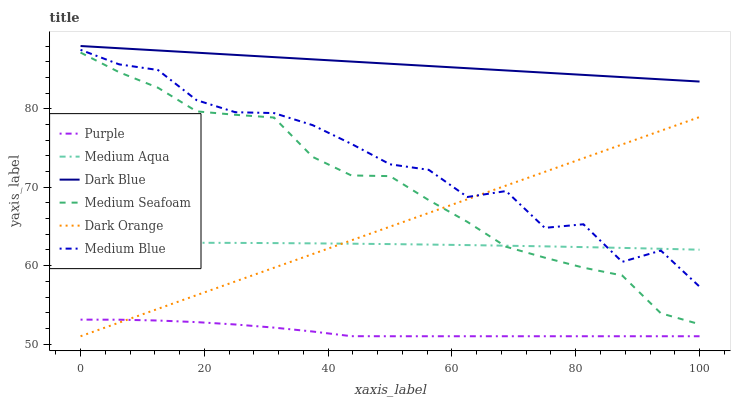Does Purple have the minimum area under the curve?
Answer yes or no. Yes. Does Dark Blue have the maximum area under the curve?
Answer yes or no. Yes. Does Medium Blue have the minimum area under the curve?
Answer yes or no. No. Does Medium Blue have the maximum area under the curve?
Answer yes or no. No. Is Dark Orange the smoothest?
Answer yes or no. Yes. Is Medium Blue the roughest?
Answer yes or no. Yes. Is Purple the smoothest?
Answer yes or no. No. Is Purple the roughest?
Answer yes or no. No. Does Dark Orange have the lowest value?
Answer yes or no. Yes. Does Medium Blue have the lowest value?
Answer yes or no. No. Does Dark Blue have the highest value?
Answer yes or no. Yes. Does Medium Blue have the highest value?
Answer yes or no. No. Is Medium Aqua less than Dark Blue?
Answer yes or no. Yes. Is Medium Blue greater than Purple?
Answer yes or no. Yes. Does Dark Orange intersect Purple?
Answer yes or no. Yes. Is Dark Orange less than Purple?
Answer yes or no. No. Is Dark Orange greater than Purple?
Answer yes or no. No. Does Medium Aqua intersect Dark Blue?
Answer yes or no. No. 